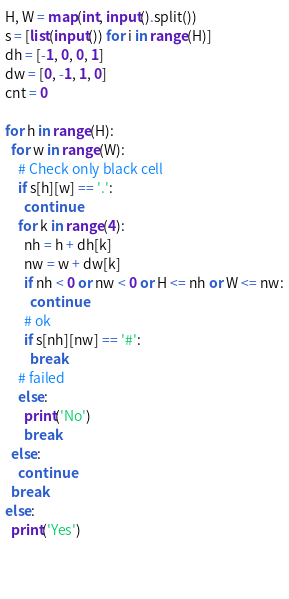<code> <loc_0><loc_0><loc_500><loc_500><_Python_>H, W = map(int, input().split())
s = [list(input()) for i in range(H)]
dh = [-1, 0, 0, 1]
dw = [0, -1, 1, 0]
cnt = 0

for h in range(H):
  for w in range(W):
    # Check only black cell
    if s[h][w] == '.':
      continue
    for k in range(4):
      nh = h + dh[k]
      nw = w + dw[k]
      if nh < 0 or nw < 0 or H <= nh or W <= nw:
        continue
      # ok
      if s[nh][nw] == '#':
        break
    # failed
    else:
      print('No')
      break
  else:
    continue
  break
else:
  print('Yes')

      
  </code> 